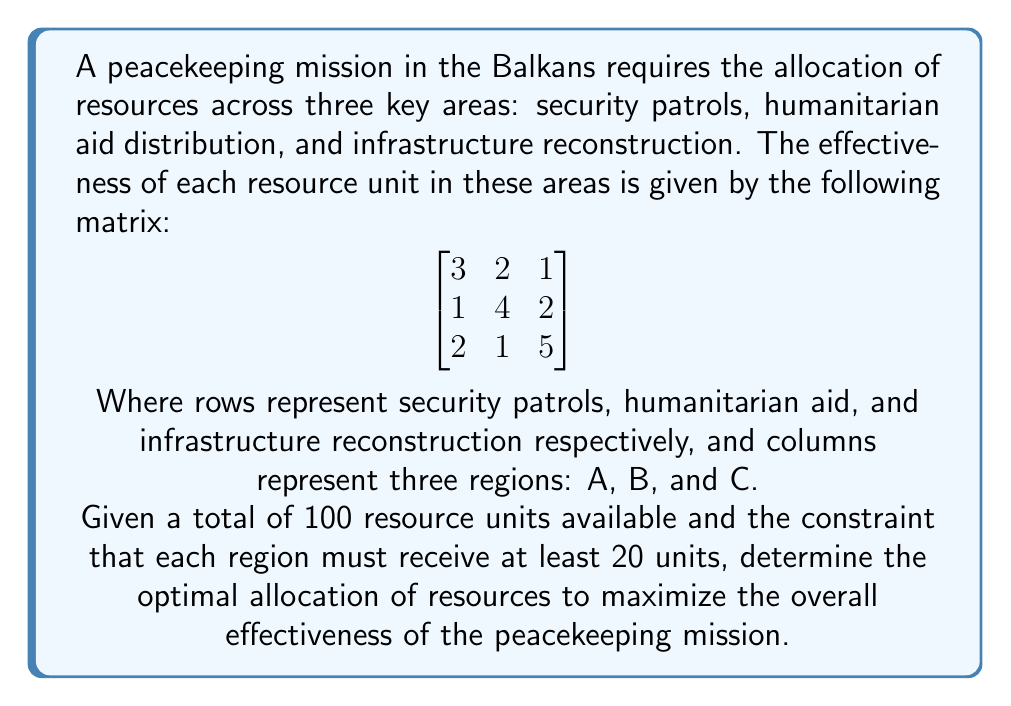Teach me how to tackle this problem. To solve this linear programming problem, we'll follow these steps:

1) Define variables:
   Let $x_1, x_2, x_3$ be the number of units allocated to regions A, B, and C respectively.

2) Formulate the objective function:
   Maximize $Z = 3x_1 + 2x_2 + x_3 + x_1 + 4x_2 + 2x_3 + 2x_1 + x_2 + 5x_3$
   Simplified: Maximize $Z = 6x_1 + 7x_2 + 8x_3$

3) Define constraints:
   $x_1 + x_2 + x_3 = 100$ (total resources)
   $x_1 \geq 20, x_2 \geq 20, x_3 \geq 20$ (minimum allocation per region)

4) Solve using the simplex method or linear programming software.

5) The optimal solution is:
   $x_1 = 20, x_2 = 20, x_3 = 60$

6) This allocation yields a maximum effectiveness of:
   $Z = 6(20) + 7(20) + 8(60) = 120 + 140 + 480 = 740$

This solution allocates the minimum required resources to regions A and B, and the remaining resources to region C, which has the highest overall effectiveness coefficient.
Answer: Region A: 20 units, Region B: 20 units, Region C: 60 units. Maximum effectiveness: 740. 